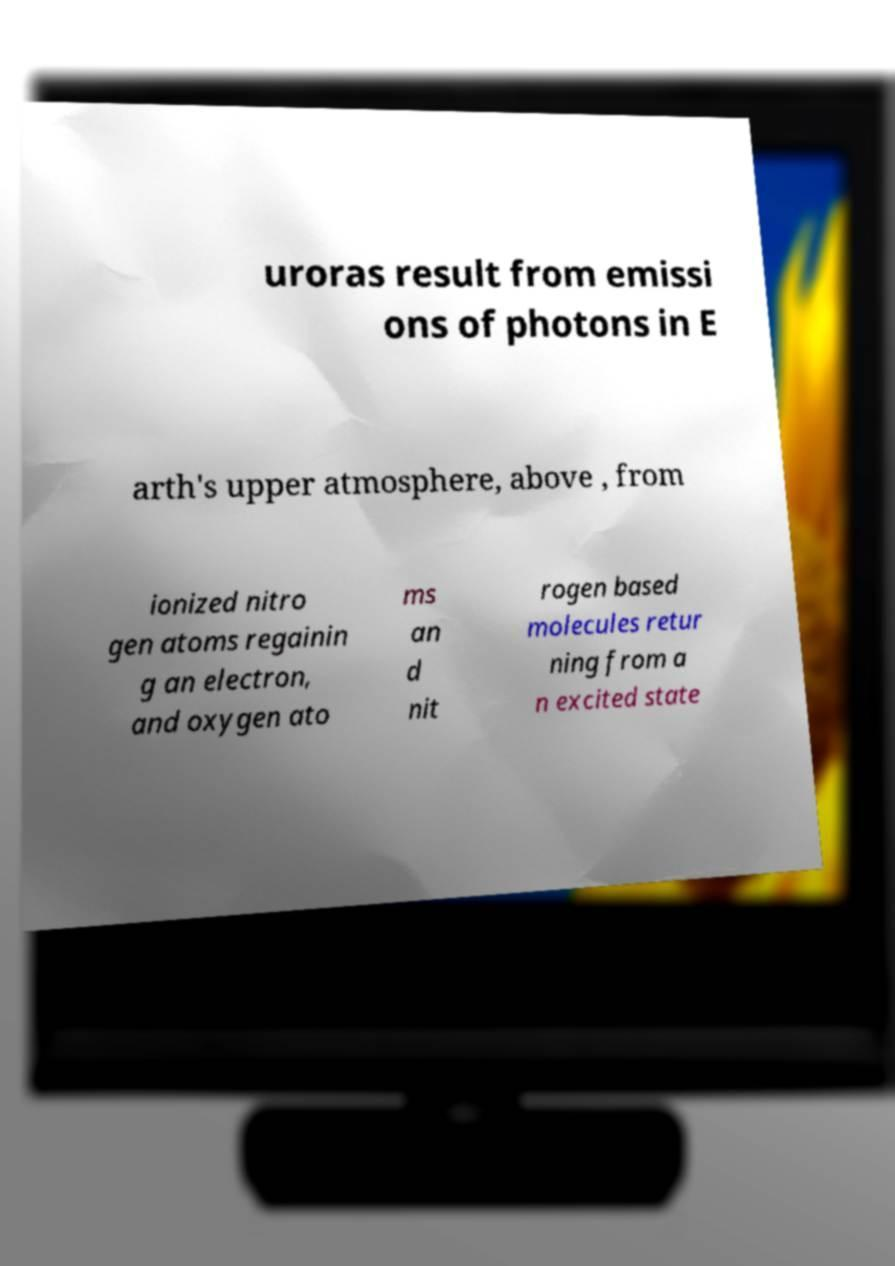Can you accurately transcribe the text from the provided image for me? uroras result from emissi ons of photons in E arth's upper atmosphere, above , from ionized nitro gen atoms regainin g an electron, and oxygen ato ms an d nit rogen based molecules retur ning from a n excited state 